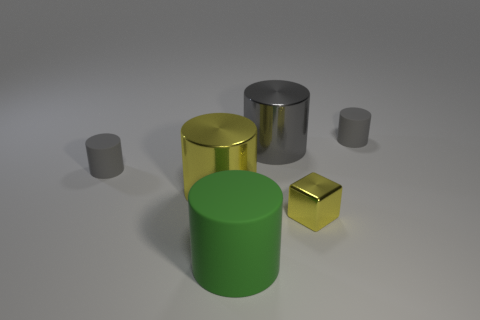There is a big gray thing; does it have the same shape as the small matte thing that is left of the large yellow shiny cylinder?
Make the answer very short. Yes. There is a rubber cylinder in front of the gray matte thing left of the yellow cylinder; how many metal objects are left of it?
Your answer should be compact. 1. What color is the shiny object that is the same size as the yellow cylinder?
Give a very brief answer. Gray. What is the size of the rubber cylinder on the left side of the yellow object that is on the left side of the tiny yellow metal object?
Your response must be concise. Small. There is another thing that is the same color as the tiny metal thing; what size is it?
Ensure brevity in your answer.  Large. What number of other things are the same size as the green rubber cylinder?
Offer a terse response. 2. How many big metal things are there?
Make the answer very short. 2. Is the size of the yellow block the same as the green object?
Ensure brevity in your answer.  No. What number of other things are the same shape as the green thing?
Provide a succinct answer. 4. What material is the gray cylinder on the left side of the big cylinder that is left of the large rubber cylinder made of?
Your response must be concise. Rubber. 